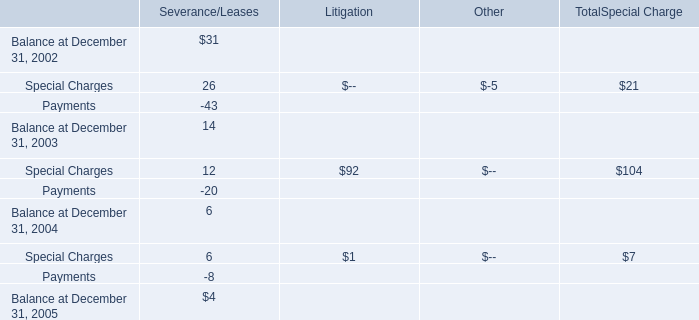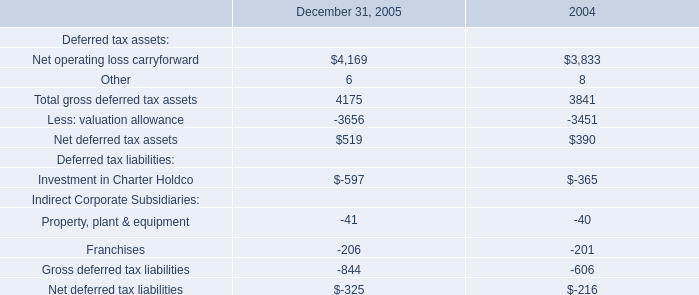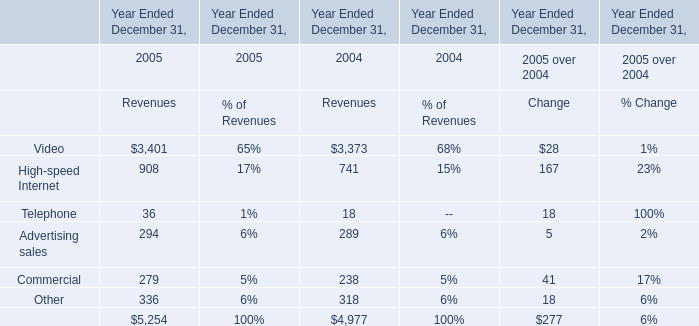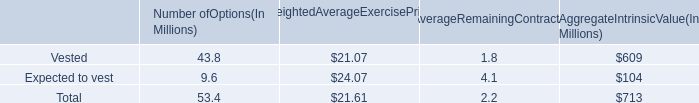as of december 26 , 2015 , what was the expected unrecognized compensation costs to be recognized per year in billions 
Computations: (1.8 / 1.2)
Answer: 1.5. 